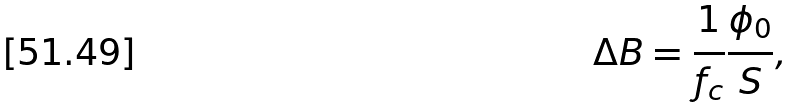Convert formula to latex. <formula><loc_0><loc_0><loc_500><loc_500>\Delta B = \frac { 1 } { f _ { c } } \frac { \phi _ { 0 } } { S } ,</formula> 